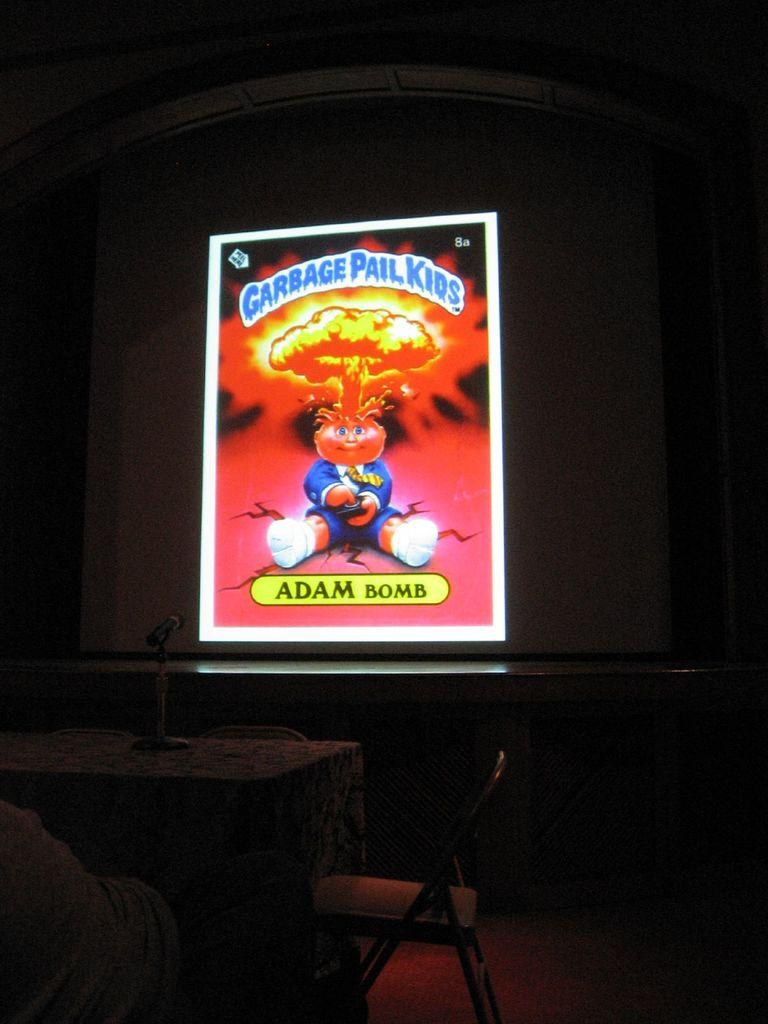What objects can be seen in the foreground of the image? There are chairs, a table, a stand, and a mic in the foreground of the image. What is the main feature in the middle of the image? There is a stage in the middle of the image. What is on the stage? There is a screen on the stage. What part of the room can be seen at the top of the image? The ceiling is visible at the part of the room visible at the top of the image. Can you see any bones on the stage in the image? There are no bones present on the stage or anywhere else in the image. What force is being applied to the tramp in the image? There is no tramp present in the image, so no force is being applied to it. 